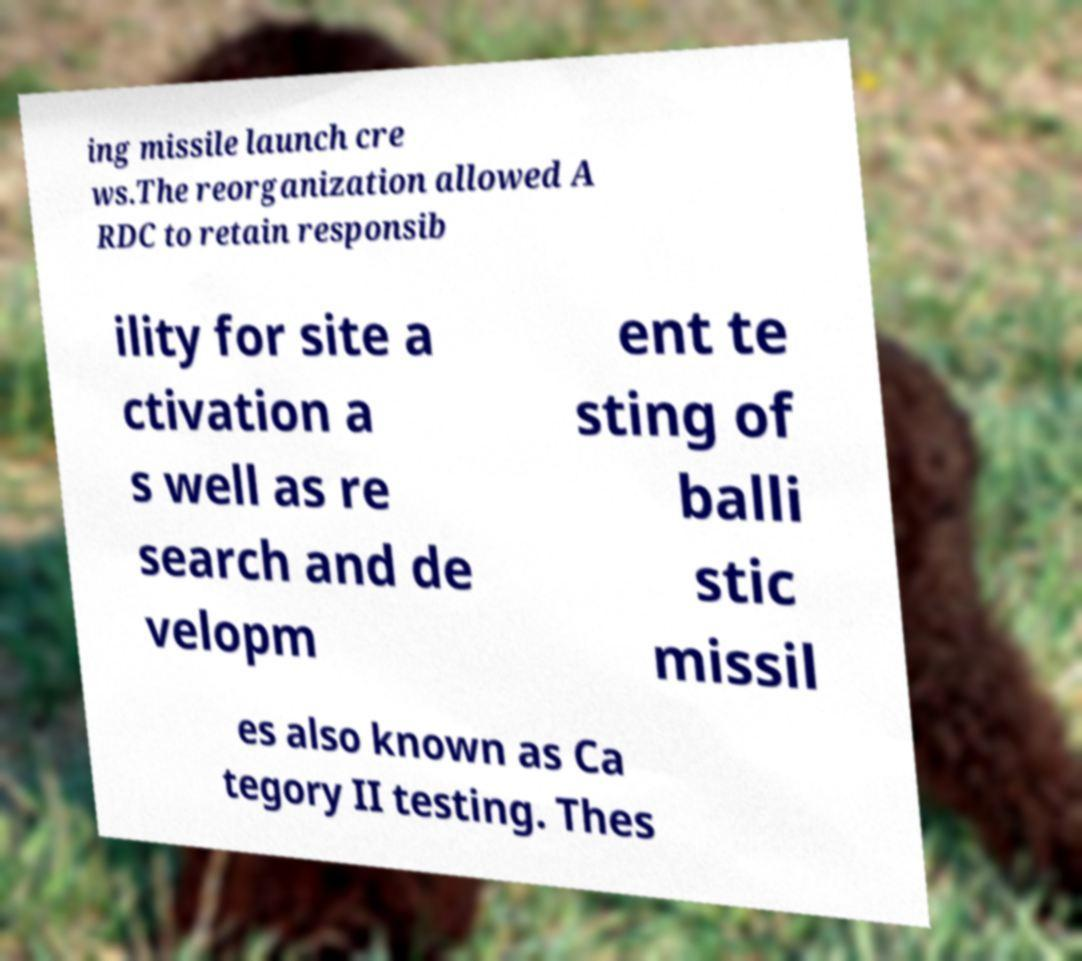What messages or text are displayed in this image? I need them in a readable, typed format. ing missile launch cre ws.The reorganization allowed A RDC to retain responsib ility for site a ctivation a s well as re search and de velopm ent te sting of balli stic missil es also known as Ca tegory II testing. Thes 